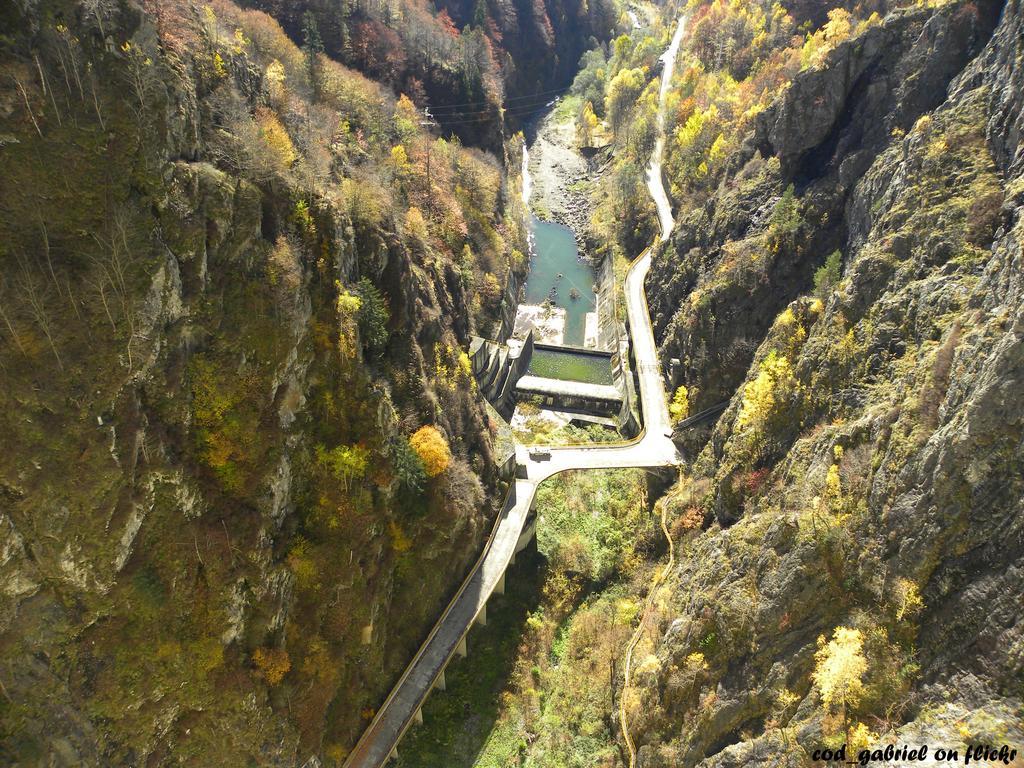How would you summarize this image in a sentence or two? In this picture we can see a few rocks on the right and left side of the image. We can see some plants. There is a water and a path. 